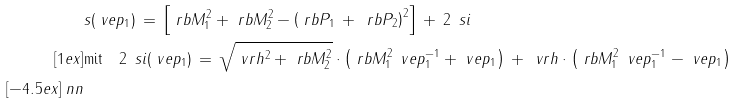Convert formula to latex. <formula><loc_0><loc_0><loc_500><loc_500>& s ( \ v e p _ { 1 } ) \, = \, \left [ \ r b { M } _ { 1 } ^ { 2 } + \ r b { M } _ { 2 } ^ { 2 } - \left ( \ r b { P } _ { 1 } \, + \, \ r b { P } _ { 2 } \right ) ^ { 2 } \right ] \, + \, 2 \, \ s i \\ [ 1 e x ] & \text {mit} \quad 2 \, \ s i ( \ v e p _ { 1 } ) \, = \, \sqrt { \ v r h ^ { 2 } + \ r b { M } _ { 2 } ^ { 2 } } \cdot \left ( \ r b { M } _ { 1 } ^ { 2 } \, \ v e p _ { 1 } ^ { - 1 } + \ v e p _ { 1 } \right ) \, + \, \ v r h \cdot \left ( \ r b { M } _ { 1 } ^ { 2 } \, \ v e p _ { 1 } ^ { - 1 } - \ v e p _ { 1 } \right ) \\ [ - 4 . 5 e x ] \ n n</formula> 